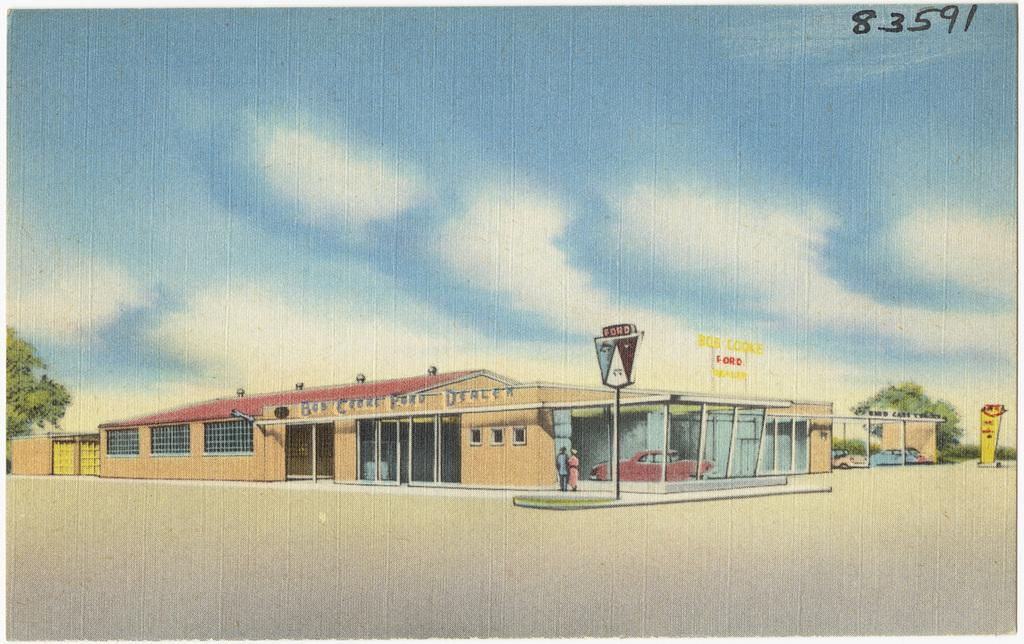<image>
Provide a brief description of the given image. a painting of a building with Dealer on the side 